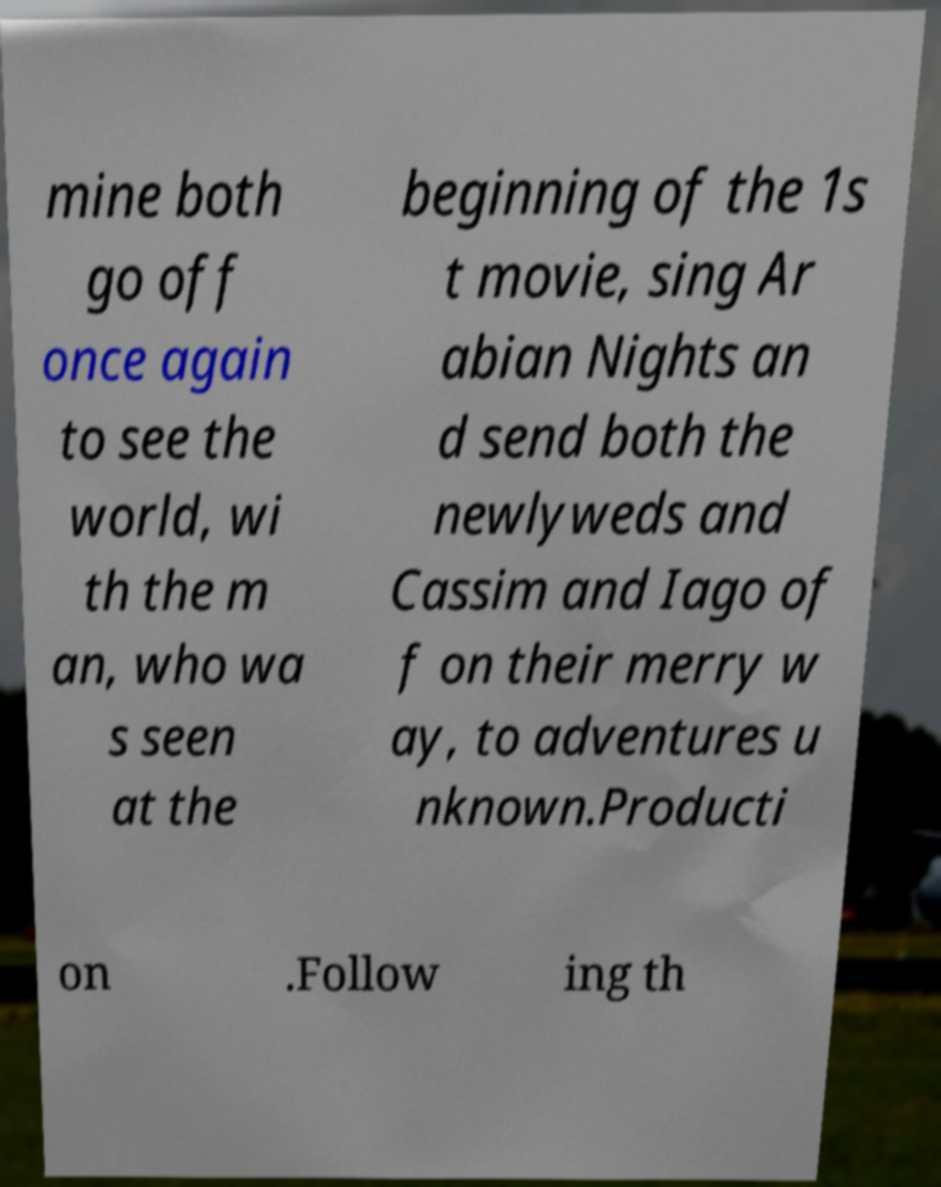Please identify and transcribe the text found in this image. mine both go off once again to see the world, wi th the m an, who wa s seen at the beginning of the 1s t movie, sing Ar abian Nights an d send both the newlyweds and Cassim and Iago of f on their merry w ay, to adventures u nknown.Producti on .Follow ing th 